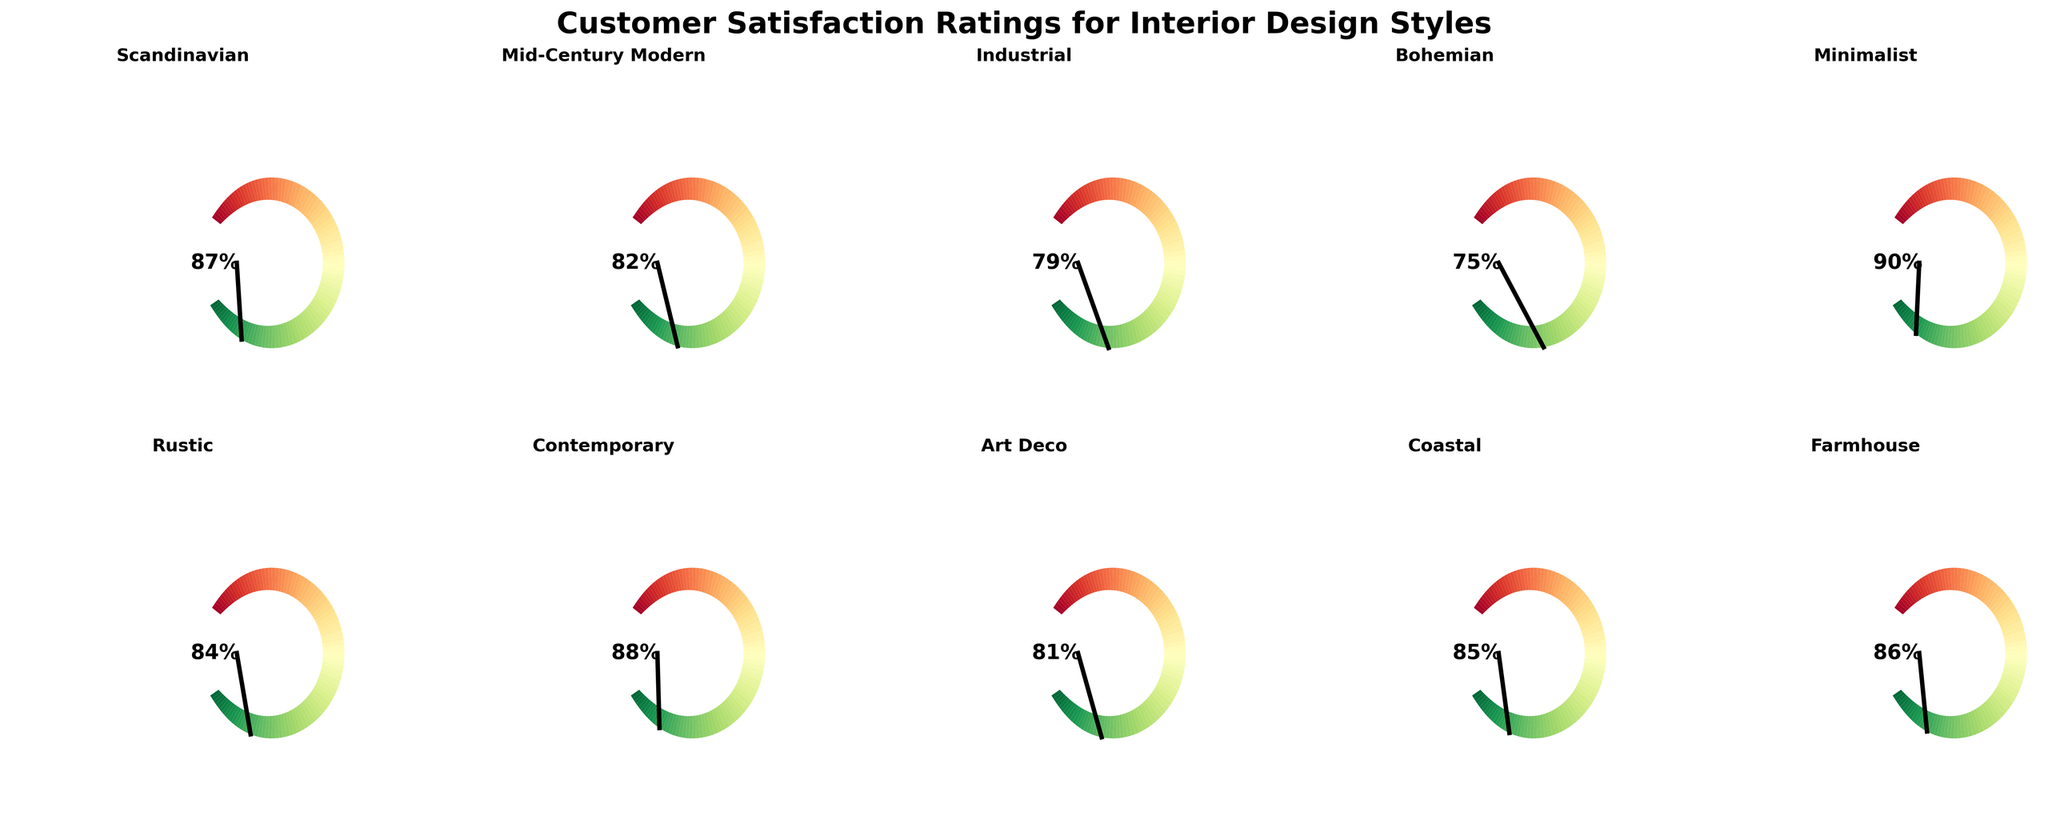What is the satisfaction rating for the Scandinavian style? By visually inspecting the gauge chart for the Scandinavian style, we can see that the needle points to 87%.
Answer: 87% Which interior design style has the highest customer satisfaction rating? Observing all the gauge charts, Minimalist has the highest rating at 90%.
Answer: Minimalist What is the average customer satisfaction rating for the shown styles? Sum all the ratings and divide by the number of styles: (87+82+79+75+90+84+88+81+85+86)/10 = 83.7%.
Answer: 83.7% What is the second highest customer satisfaction rating, and which style does it belong to? The second highest rating is 88%, belonging to the Contemporary style.
Answer: Contemporary How much higher is the satisfaction rating for the Minimalist style compared to the Bohemian style? Subtract the Bohemian rating from the Minimalist rating: 90% - 75% = 15%.
Answer: 15% What style has the closest satisfaction rating to 80%? Comparing to 80%, the closest style is Art Deco with a rating of 81%.
Answer: Art Deco Which styles have a customer satisfaction rating above 85%? The styles with ratings above 85% are Minimalist (90%), Contemporary (88%), and Scandinavian (87%).
Answer: Minimalist, Contemporary, Scandinavian What is the difference in satisfaction ratings between Industrial and Coastal? Subtract the Industrial rating from the Coastal rating: 85% - 79% = 6%.
Answer: 6% How many styles have a satisfaction rating below 80%? By counting the ratings below 80%, there are two styles: Industrial (79%) and Bohemian (75%).
Answer: 2 What is the range of customer satisfaction ratings for the given styles? The range is the difference between the highest and lowest ratings: 90% (Minimalist) - 75% (Bohemian) = 15%.
Answer: 15% 